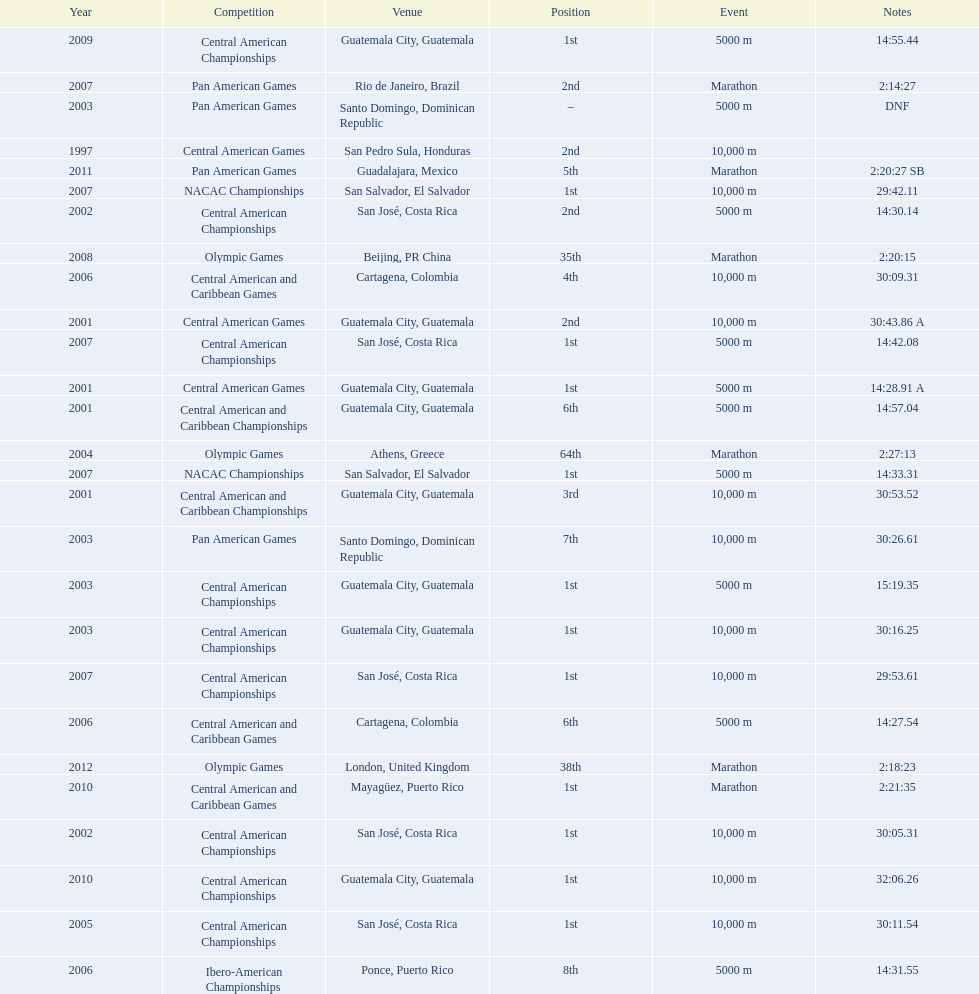Tell me the number of times they competed in guatamala. 5. 